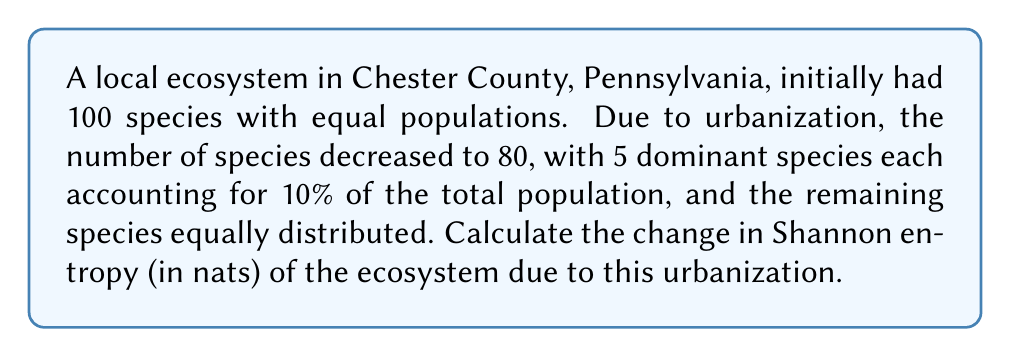Show me your answer to this math problem. Let's approach this step-by-step:

1) Shannon entropy is given by the formula:
   $$H = -\sum_{i=1}^{n} p_i \ln(p_i)$$
   where $p_i$ is the proportion of individuals belonging to species $i$.

2) Initial state:
   - 100 species with equal populations
   - Probability for each species: $p_i = \frac{1}{100} = 0.01$
   - Initial entropy: 
     $$H_1 = -100 \cdot (0.01 \ln(0.01)) = -100 \cdot (-0.04605) = 4.605\text{ nats}$$

3) Final state:
   - 80 species total
   - 5 dominant species, each with 10% of population
   - 75 remaining species, equally distributed among 50% of population

4) Calculate probabilities for final state:
   - For each dominant species: $p_d = 0.1$
   - For each remaining species: $p_r = \frac{0.5}{75} = \frac{1}{150} \approx 0.00667$

5) Calculate final entropy:
   $$\begin{align}
   H_2 &= -5 \cdot (0.1 \ln(0.1)) - 75 \cdot (\frac{1}{150} \ln(\frac{1}{150})) \\
   &= -5 \cdot (-0.23026) - 75 \cdot (-0.03338) \\
   &= 1.15130 + 2.50350 \\
   &= 3.65480\text{ nats}
   \end{align}$$

6) Calculate the change in entropy:
   $$\Delta H = H_2 - H_1 = 3.65480 - 4.605 = -0.95020\text{ nats}$$
Answer: $-0.95020\text{ nats}$ 